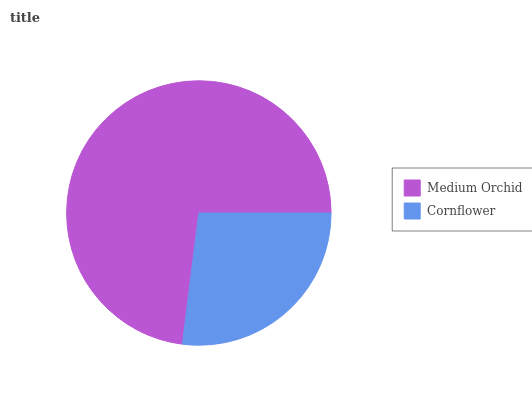Is Cornflower the minimum?
Answer yes or no. Yes. Is Medium Orchid the maximum?
Answer yes or no. Yes. Is Cornflower the maximum?
Answer yes or no. No. Is Medium Orchid greater than Cornflower?
Answer yes or no. Yes. Is Cornflower less than Medium Orchid?
Answer yes or no. Yes. Is Cornflower greater than Medium Orchid?
Answer yes or no. No. Is Medium Orchid less than Cornflower?
Answer yes or no. No. Is Medium Orchid the high median?
Answer yes or no. Yes. Is Cornflower the low median?
Answer yes or no. Yes. Is Cornflower the high median?
Answer yes or no. No. Is Medium Orchid the low median?
Answer yes or no. No. 